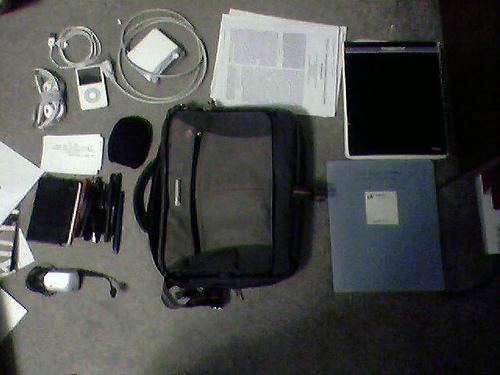Is there a person in this picture?
Quick response, please. No. How many ipods are in the picture?
Give a very brief answer. 1. Does the bag have a zipper pouch?
Be succinct. Yes. 